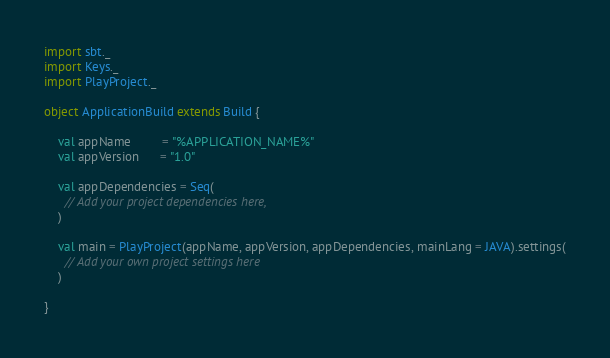<code> <loc_0><loc_0><loc_500><loc_500><_Scala_>import sbt._
import Keys._
import PlayProject._

object ApplicationBuild extends Build {

    val appName         = "%APPLICATION_NAME%"
    val appVersion      = "1.0"

    val appDependencies = Seq(
      // Add your project dependencies here,
    )

    val main = PlayProject(appName, appVersion, appDependencies, mainLang = JAVA).settings(
      // Add your own project settings here      
    )

}
</code> 